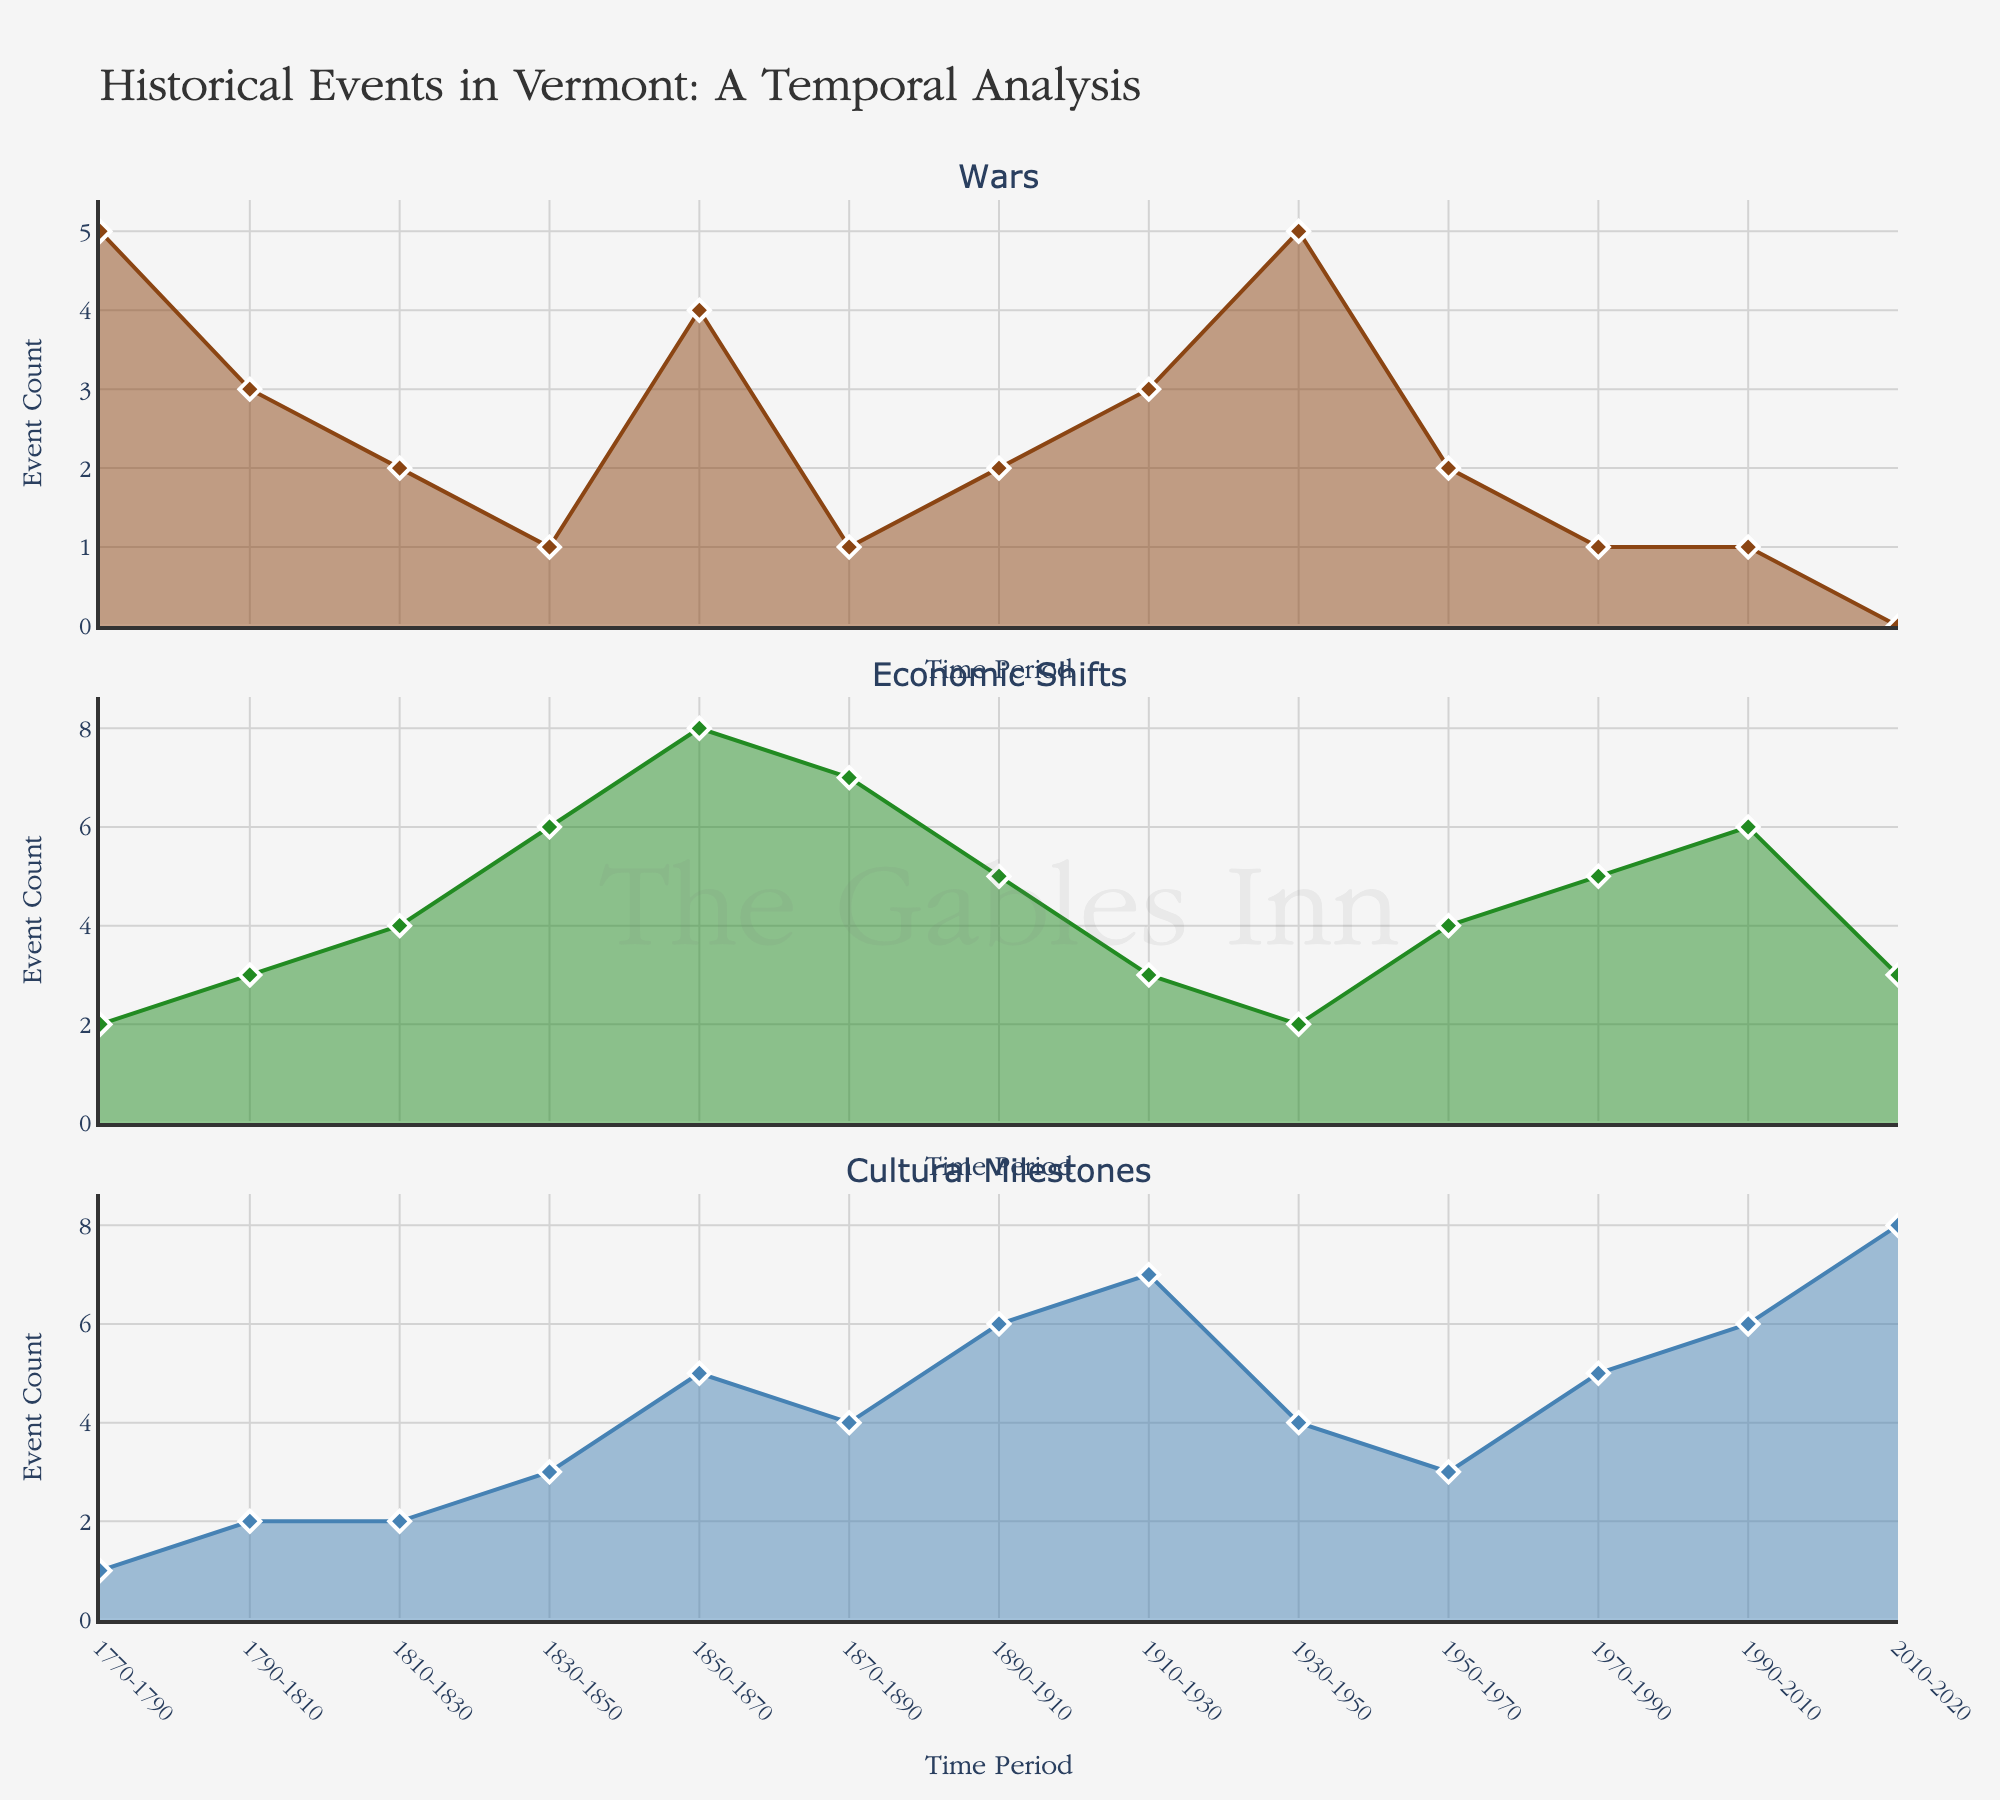How many wars were documented between 1850 and 1870? Looking at the subplot for wars, count the events in the period 1850-1870, which shows 4 events.
Answer: 4 Which time period had the highest number of economic shifts documented? From the subplot for economic shifts, the highest peak is at the period 1850-1870 with a count of 8 events.
Answer: 1850-1870 During which time period did documented cultural milestones begin to rise significantly? Observing the Cultural Milestones subplot, the significant rise starts at the 1850-1870 period, moving from 3 to 5 events.
Answer: 1850-1870 How many more cultural milestones were documented in 2010-2020 compared to 1770-1790? Check the values in the Cultural Milestones subplot: 2010-2020 has 8 events and 1770-1790 has 1 event. The difference is 8 - 1.
Answer: 7 Which category had the least number of events documented in the most recent period (2010-2020)? Comparing the recent period data for all categories, wars had 0, economic shifts had 3, and cultural milestones had 8 documented events.
Answer: Wars What is the total number of wars documented from 1770 to 1930? Sum the event counts from all periods between 1770 to 1930 in the Wars subplot: 5 + 3 + 2 + 1 + 4 + 1 + 2 + 3 = 21.
Answer: 21 How does the trend of economic shifts compare between 1850-1870 and 2010-2020? In the Economic Shifts subplot, 1850-1870 shows a peak with 8 events while 2010-2020 shows a decline with only 3 events.
Answer: 1850-1870 has more What is the average number of cultural milestones documented across all periods? Sum all data points in the Cultural Milestones subplot: 1 + 2 + 2 + 3 + 5 + 4 + 6 + 7 + 4 + 3 + 5 + 6 + 8 = 56, then divide by 13 periods. 56 / 13 ≈ 4.31.
Answer: 4.31 In which time period are the numbers of wars, economic shifts, and cultural milestones all equal? By analyzing each subplot, find no period where all three counts are equal across the 13 periods.
Answer: No period 